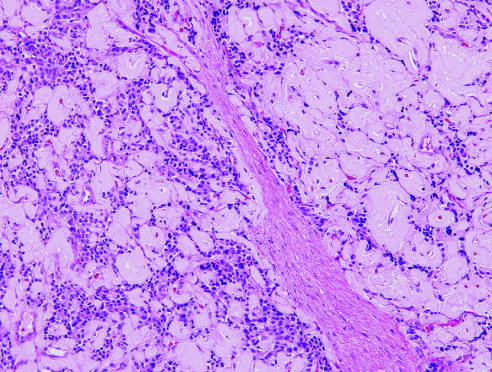what is abundant amyloid deposition?
Answer the question using a single word or phrase. Characteristic of an insulinoma 